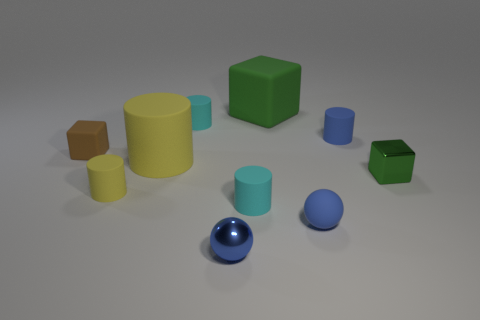The big block that is the same material as the tiny brown cube is what color?
Your answer should be very brief. Green. How many small blue objects have the same material as the brown object?
Provide a short and direct response. 2. Does the matte ball have the same color as the tiny matte cube that is behind the small green thing?
Your answer should be compact. No. The tiny matte sphere that is right of the cyan thing in front of the tiny blue cylinder is what color?
Provide a short and direct response. Blue. What is the color of the other shiny cube that is the same size as the brown cube?
Provide a succinct answer. Green. Are there any green matte objects of the same shape as the brown matte object?
Your answer should be very brief. Yes. What is the shape of the green shiny thing?
Your answer should be very brief. Cube. Are there more yellow objects to the left of the tiny blue cylinder than large things that are left of the brown rubber object?
Provide a succinct answer. Yes. What number of other things are the same size as the metal ball?
Offer a very short reply. 7. There is a cube that is in front of the big green thing and left of the blue rubber sphere; what material is it made of?
Offer a very short reply. Rubber. 